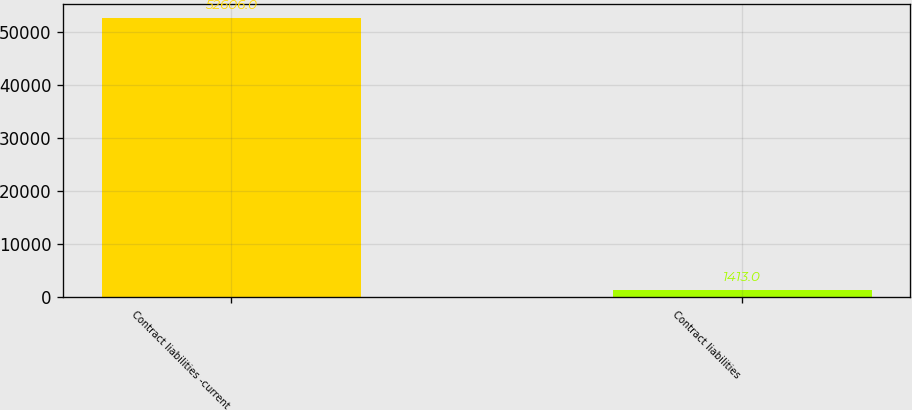Convert chart to OTSL. <chart><loc_0><loc_0><loc_500><loc_500><bar_chart><fcel>Contract liabilities -current<fcel>Contract liabilities<nl><fcel>52606<fcel>1413<nl></chart> 